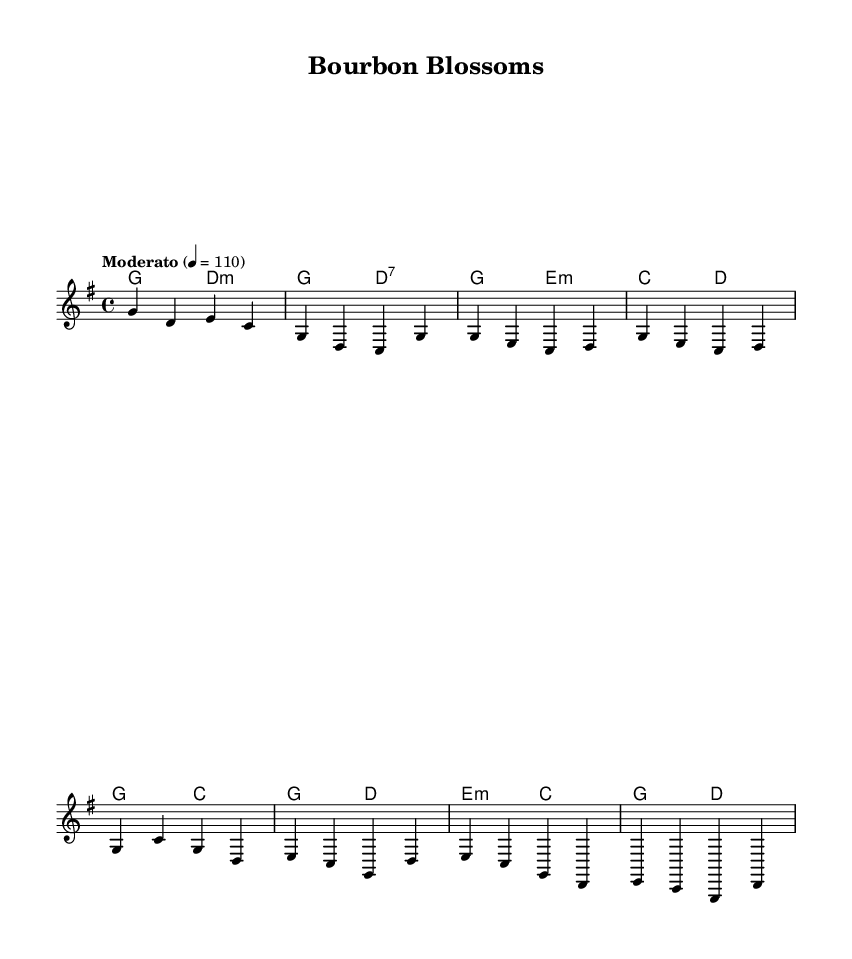What is the key signature of this music? The key signature indicated in the score is G major, which has one sharp (F#). This is determined by the presence of the F# note in the context of the scale, and there are no natural or flat symbols that modify other notes in the signature.
Answer: G major What is the time signature of this music? The time signature shown in the score is 4/4, which indicates four beats per measure and the quarter note receives one beat. This is analyzed by looking at the two numbers at the beginning of the score; the top number represents the number of beats in a measure, while the bottom number indicates which note value constitutes one beat.
Answer: 4/4 What is the tempo marking for this piece? The tempo marking specified in the score is Moderato, indicated by the text in the tempo line, which means moderately fast. This is established from the term written above the staff, giving a descriptive insight into the intended speed of performance.
Answer: Moderato How many sections does the piece have? The piece contains three sections identifiable by distinct labels such as Intro, Verse, Chorus, and Bridge marked within the music. This can be counted by looking at the different headings that denote structural changes in the music.
Answer: 4 What chord follows the first measure of the Chorus? The first measure of the Chorus has a G chord followed by a C chord. This is derived from checking the chord symbols aligned with the melody, where each measure corresponds with the harmonies provided.
Answer: C Which voice is indicated in this score for the melody? The score denotes the melody to be played by the lead voice, as indicated in the voice naming section of the staff. This can be recognized by examining the label next to "new Voice" which explicitly states the role of the melody within the arrangement.
Answer: Lead 